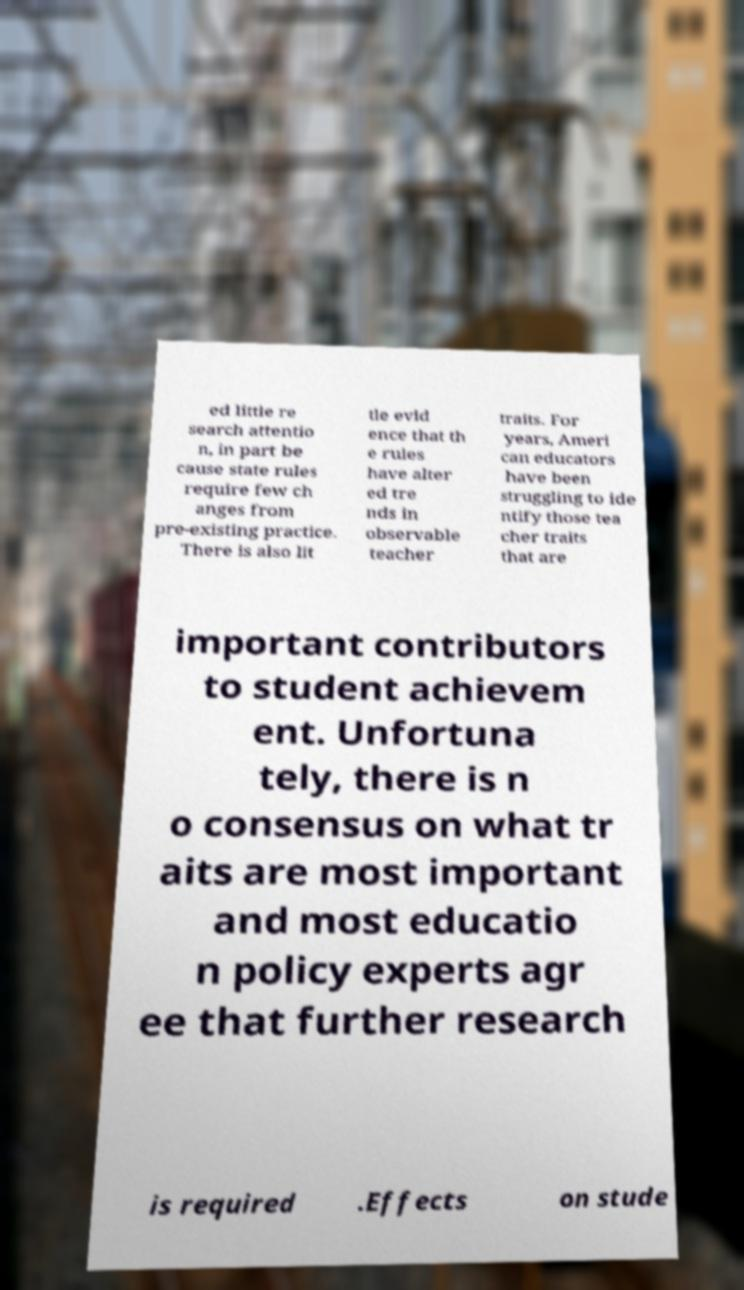Can you read and provide the text displayed in the image?This photo seems to have some interesting text. Can you extract and type it out for me? ed little re search attentio n, in part be cause state rules require few ch anges from pre-existing practice. There is also lit tle evid ence that th e rules have alter ed tre nds in observable teacher traits. For years, Ameri can educators have been struggling to ide ntify those tea cher traits that are important contributors to student achievem ent. Unfortuna tely, there is n o consensus on what tr aits are most important and most educatio n policy experts agr ee that further research is required .Effects on stude 